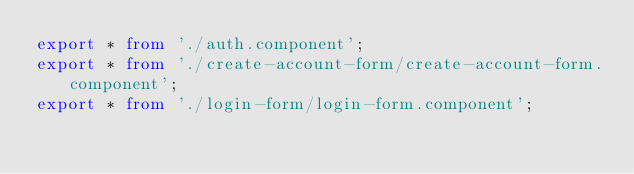<code> <loc_0><loc_0><loc_500><loc_500><_TypeScript_>export * from './auth.component';
export * from './create-account-form/create-account-form.component';
export * from './login-form/login-form.component';
</code> 